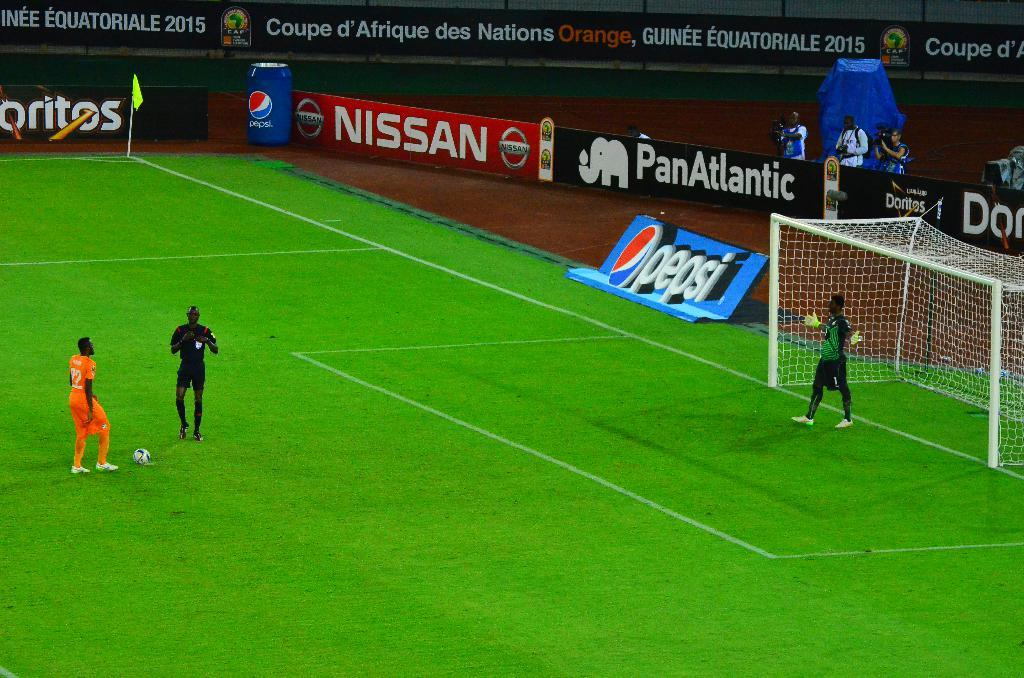<image>
Write a terse but informative summary of the picture. Pepsi, Nissan and Doritos sponsor a soccer stadium 